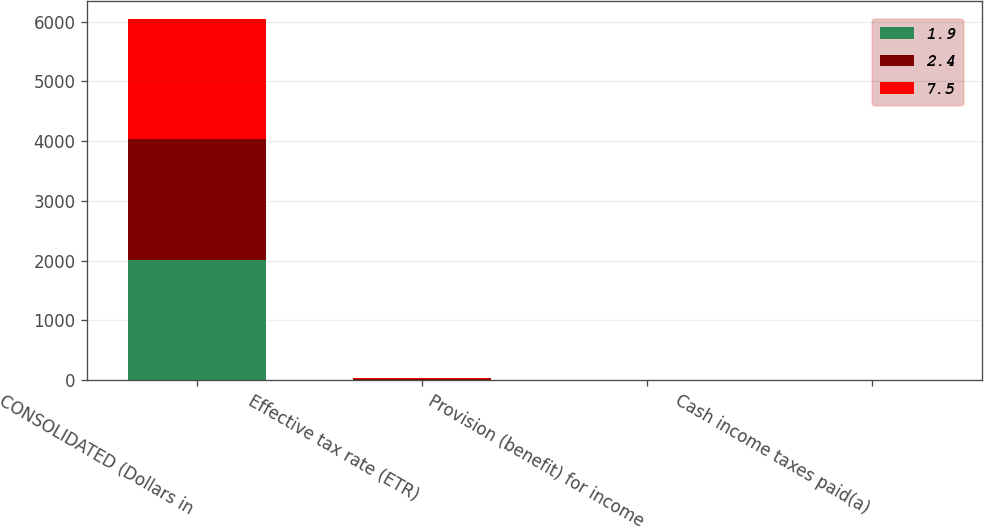<chart> <loc_0><loc_0><loc_500><loc_500><stacked_bar_chart><ecel><fcel>CONSOLIDATED (Dollars in<fcel>Effective tax rate (ETR)<fcel>Provision (benefit) for income<fcel>Cash income taxes paid(a)<nl><fcel>1.9<fcel>2018<fcel>2.9<fcel>0.6<fcel>1.9<nl><fcel>2.4<fcel>2017<fcel>23.4<fcel>2.6<fcel>2.4<nl><fcel>7.5<fcel>2016<fcel>16.1<fcel>1.1<fcel>7.5<nl></chart> 